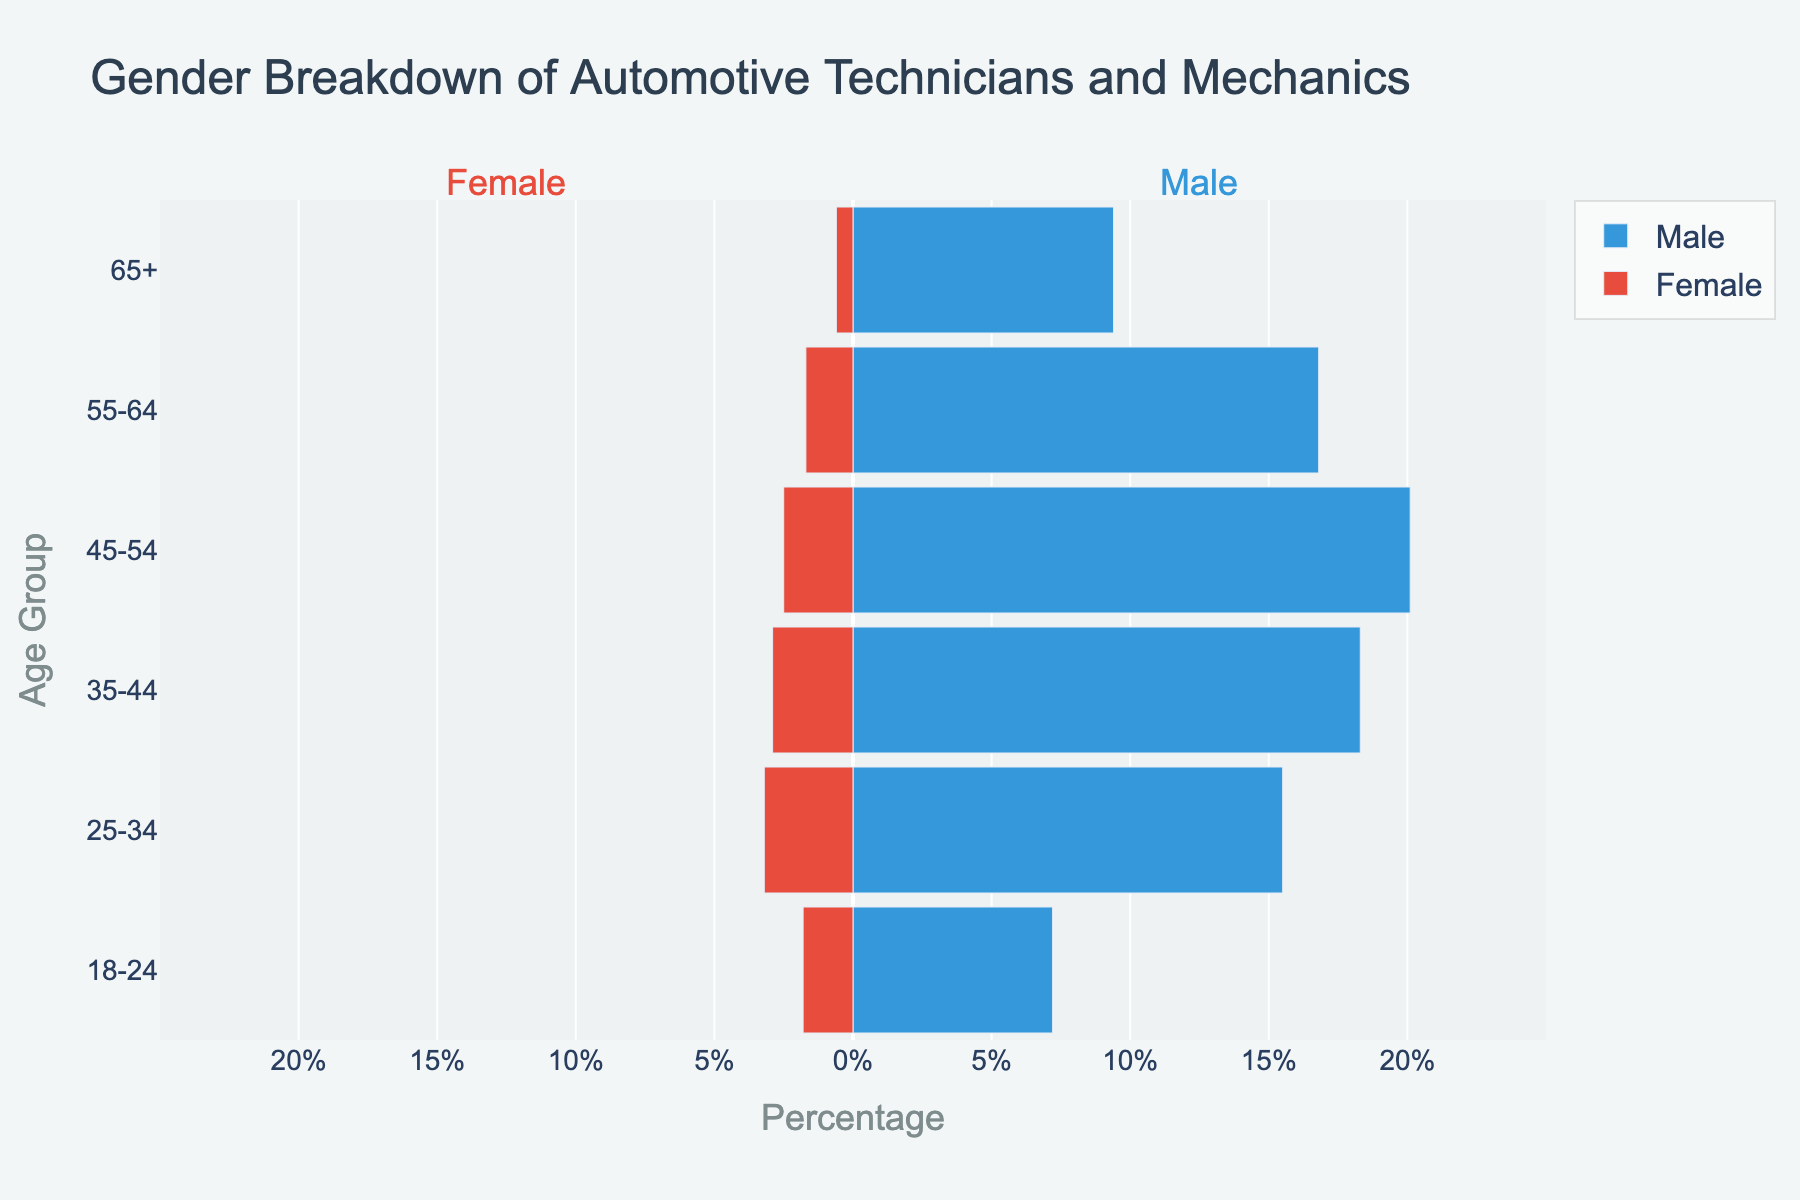What is the title of the chart? The title is displayed at the top of the figure.
Answer: Gender Breakdown of Automotive Technicians and Mechanics Which age group has the highest percentage of male automotive technicians and mechanics? The percentage for each age group is represented by the width of the blue bars. The widest bar for males is in the 45-54 age group.
Answer: 45-54 How many age groups are shown in the figure? The age groups are represented on the y-axis. By counting the number of entries, it shows there are 6 age groups.
Answer: 6 For the 25-34 age group, what is the difference in percentage between males and females? For the 25-34 age group, the male percentage is 15.5% and the female percentage is 3.2%. The difference is calculated as 15.5% - 3.2%.
Answer: 12.3% Which gender has a higher percentage in the 18-24 age group? The percentage for males is 7.2%, and for females, it is 1.8%. Since 7.2% is greater than 1.8%, males have a higher percentage.
Answer: Male Which age group shows the least percentage of female automotive technicians and mechanics? The y-axis shows the different age groups, and the shortest red bar indicates the lowest percentage, which is in the 65+ age group at 0.6%.
Answer: 65+ What is the combined percentage of male and female automotive technicians and mechanics in the 35-44 age group? The male percentage is 18.3% and the female percentage is 2.9%. Adding these together gives 18.3% + 2.9%.
Answer: 21.2% In which age group is the gender disparity (difference between male and female percentages) the smallest? The gender disparity for each age group can be calculated. The 55-64 age group has the closest percentages: 16.8% - 1.7% = 15.1%, which is the smallest disparity compared to other groups.
Answer: 55-64 Which age group represents the peak of female automotive technicians and mechanics? The red bars represent the percentage of females in each age group. The widest red bar is for the 25-34 age group.
Answer: 25-34 What is the overall trend in male percentages across the age groups from 18-24 to 65+? Observing the blue bars from 18-24 to 65+, the trend shows an initial increase, peaking at 45-54, and then a decrease towards the 65+ age group.
Answer: Increase then decrease 